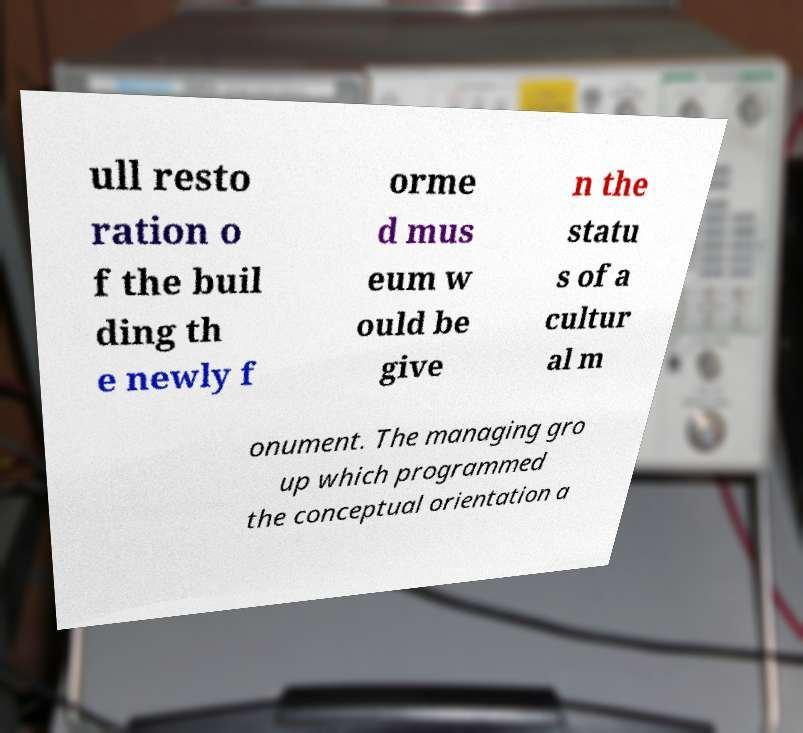Could you assist in decoding the text presented in this image and type it out clearly? ull resto ration o f the buil ding th e newly f orme d mus eum w ould be give n the statu s of a cultur al m onument. The managing gro up which programmed the conceptual orientation a 